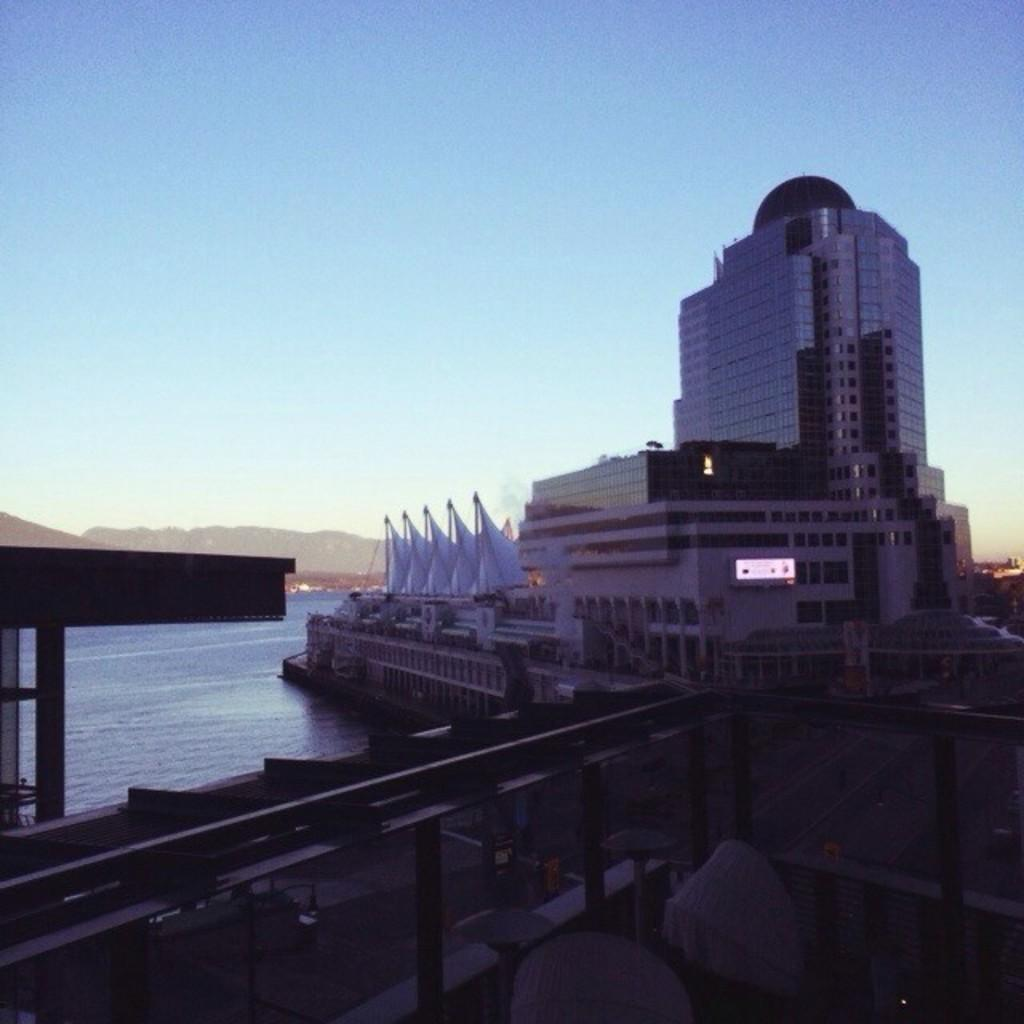What is the main subject of the image? There is a ship in the image. Where is the ship located? The ship is on the water. What can be seen in the background of the image? There are buildings in the background of the image. How would you describe the color of the sky in the image? The sky is blue and white in color. What type of silver is being used for digestion on the ship in the image? There is no silver or digestion process mentioned or depicted in the image. 